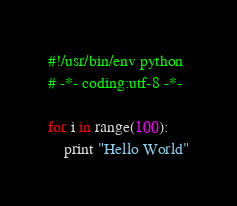<code> <loc_0><loc_0><loc_500><loc_500><_Python_>#!/usr/bin/env python
# -*- coding:utf-8 -*-

for i in range(100):
	print "Hello World"</code> 